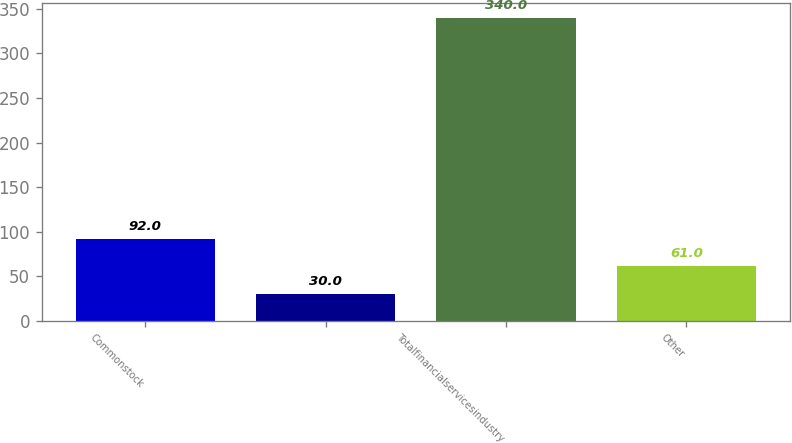<chart> <loc_0><loc_0><loc_500><loc_500><bar_chart><fcel>Commonstock<fcel>Unnamed: 1<fcel>Totalfinancialservicesindustry<fcel>Other<nl><fcel>92<fcel>30<fcel>340<fcel>61<nl></chart> 